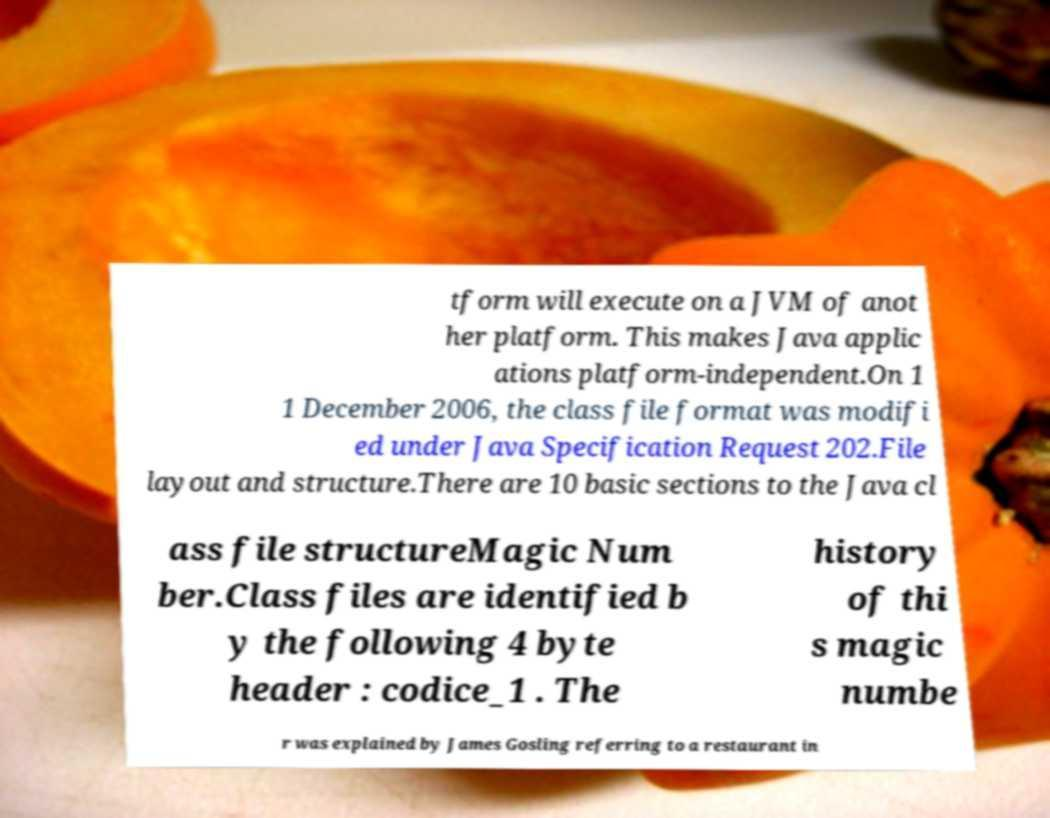Can you read and provide the text displayed in the image?This photo seems to have some interesting text. Can you extract and type it out for me? tform will execute on a JVM of anot her platform. This makes Java applic ations platform-independent.On 1 1 December 2006, the class file format was modifi ed under Java Specification Request 202.File layout and structure.There are 10 basic sections to the Java cl ass file structureMagic Num ber.Class files are identified b y the following 4 byte header : codice_1 . The history of thi s magic numbe r was explained by James Gosling referring to a restaurant in 